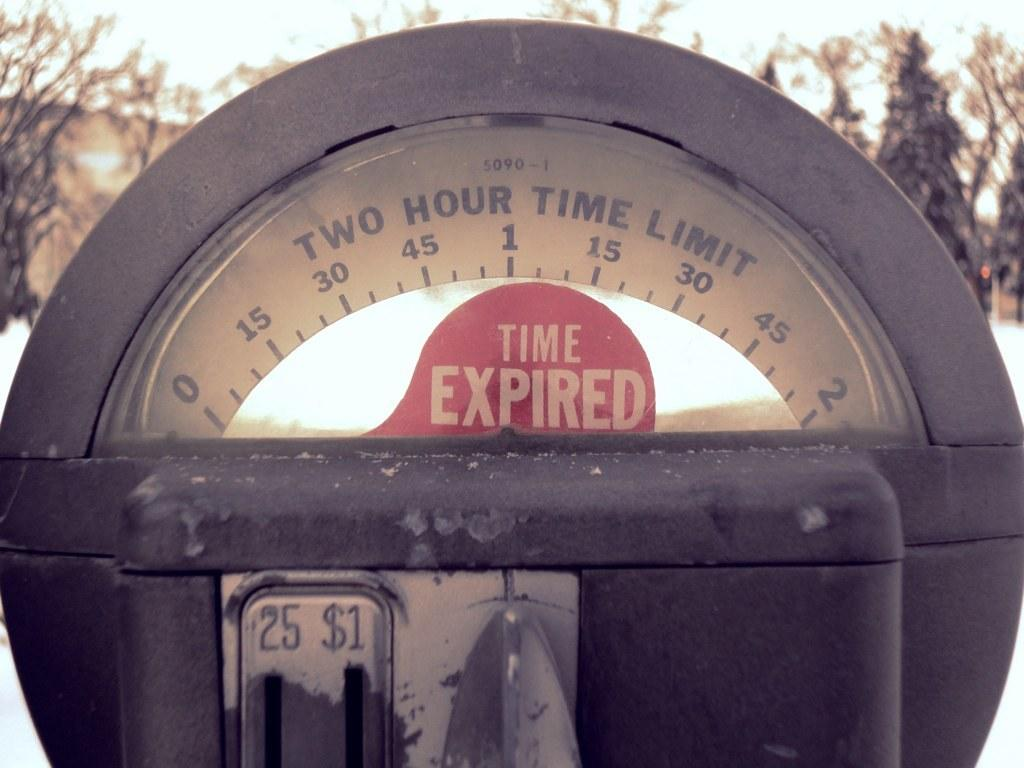Provide a one-sentence caption for the provided image. a close up of a parking meter reading Time Expired. 